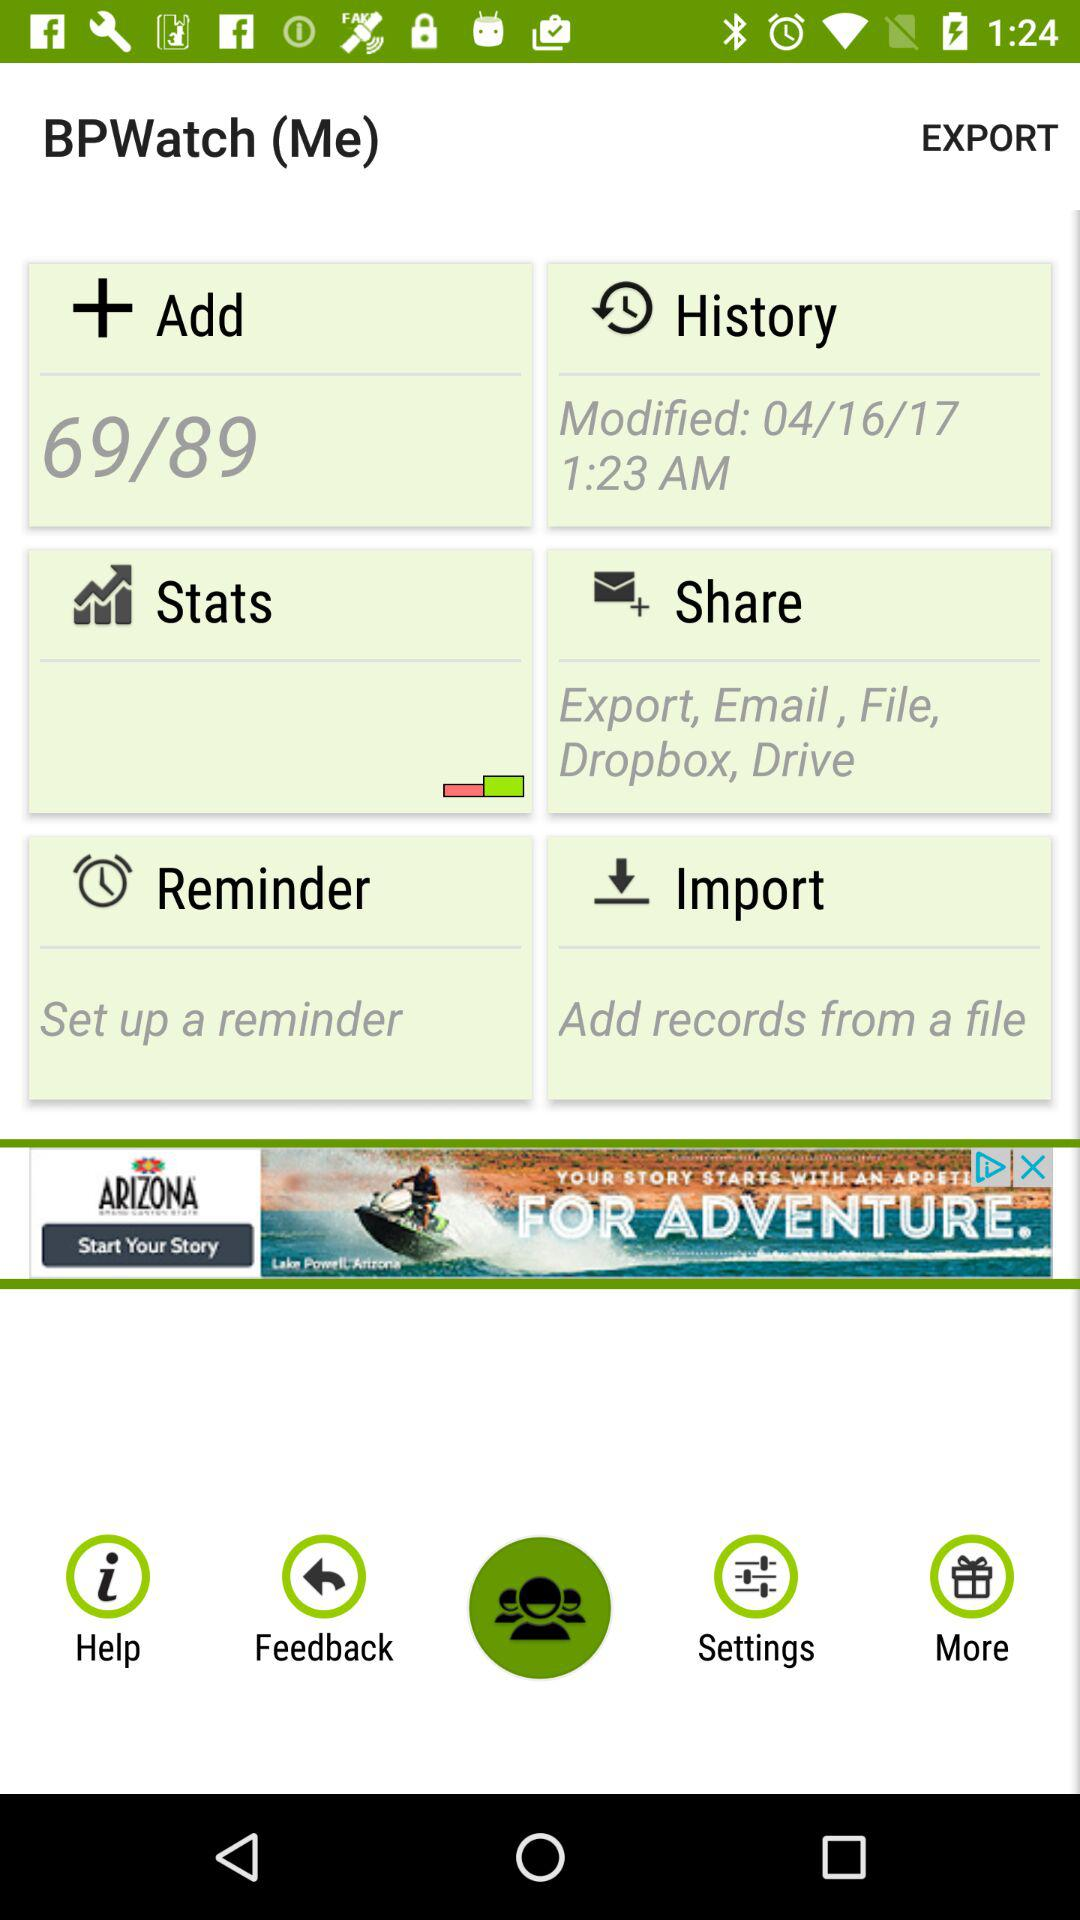Through which option can we share the content? The options are "Export", "Email", "File", "Dropbox" and "Drive". 